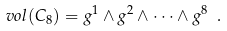Convert formula to latex. <formula><loc_0><loc_0><loc_500><loc_500>\ v o l ( C _ { 8 } ) = g ^ { 1 } \wedge g ^ { 2 } \wedge \dots \wedge g ^ { 8 } \ .</formula> 